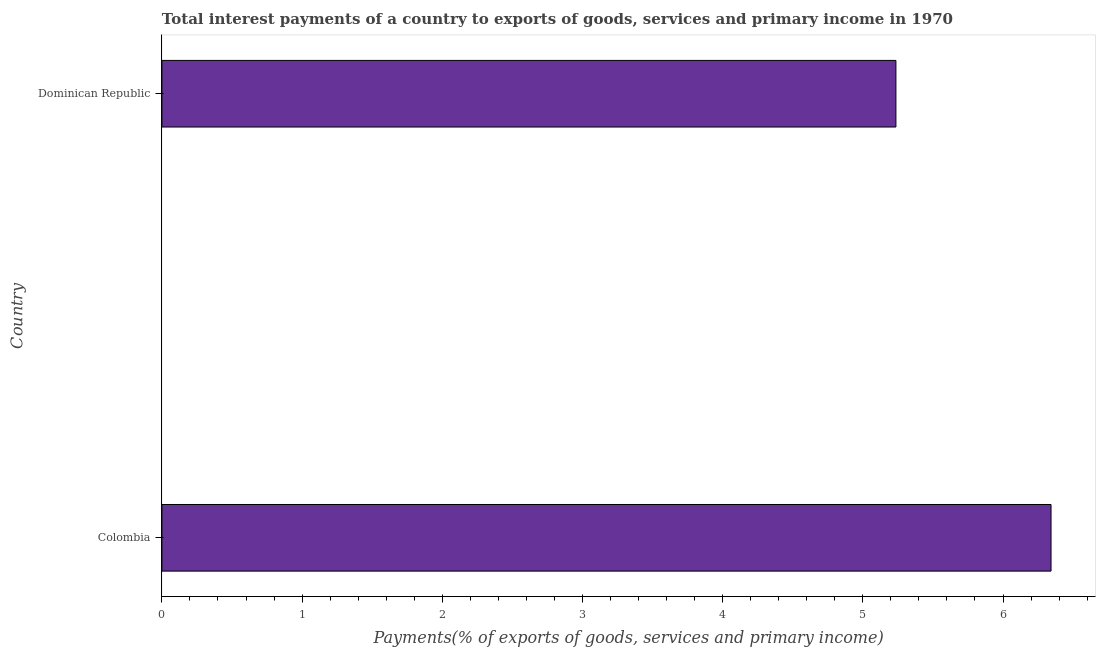What is the title of the graph?
Your answer should be very brief. Total interest payments of a country to exports of goods, services and primary income in 1970. What is the label or title of the X-axis?
Offer a very short reply. Payments(% of exports of goods, services and primary income). What is the label or title of the Y-axis?
Give a very brief answer. Country. What is the total interest payments on external debt in Dominican Republic?
Offer a terse response. 5.24. Across all countries, what is the maximum total interest payments on external debt?
Your answer should be compact. 6.34. Across all countries, what is the minimum total interest payments on external debt?
Provide a short and direct response. 5.24. In which country was the total interest payments on external debt minimum?
Ensure brevity in your answer.  Dominican Republic. What is the sum of the total interest payments on external debt?
Keep it short and to the point. 11.58. What is the difference between the total interest payments on external debt in Colombia and Dominican Republic?
Your answer should be very brief. 1.11. What is the average total interest payments on external debt per country?
Your answer should be very brief. 5.79. What is the median total interest payments on external debt?
Your answer should be very brief. 5.79. What is the ratio of the total interest payments on external debt in Colombia to that in Dominican Republic?
Provide a succinct answer. 1.21. Is the total interest payments on external debt in Colombia less than that in Dominican Republic?
Keep it short and to the point. No. In how many countries, is the total interest payments on external debt greater than the average total interest payments on external debt taken over all countries?
Keep it short and to the point. 1. Are all the bars in the graph horizontal?
Offer a very short reply. Yes. How many countries are there in the graph?
Offer a terse response. 2. What is the Payments(% of exports of goods, services and primary income) in Colombia?
Keep it short and to the point. 6.34. What is the Payments(% of exports of goods, services and primary income) of Dominican Republic?
Offer a terse response. 5.24. What is the difference between the Payments(% of exports of goods, services and primary income) in Colombia and Dominican Republic?
Make the answer very short. 1.11. What is the ratio of the Payments(% of exports of goods, services and primary income) in Colombia to that in Dominican Republic?
Give a very brief answer. 1.21. 